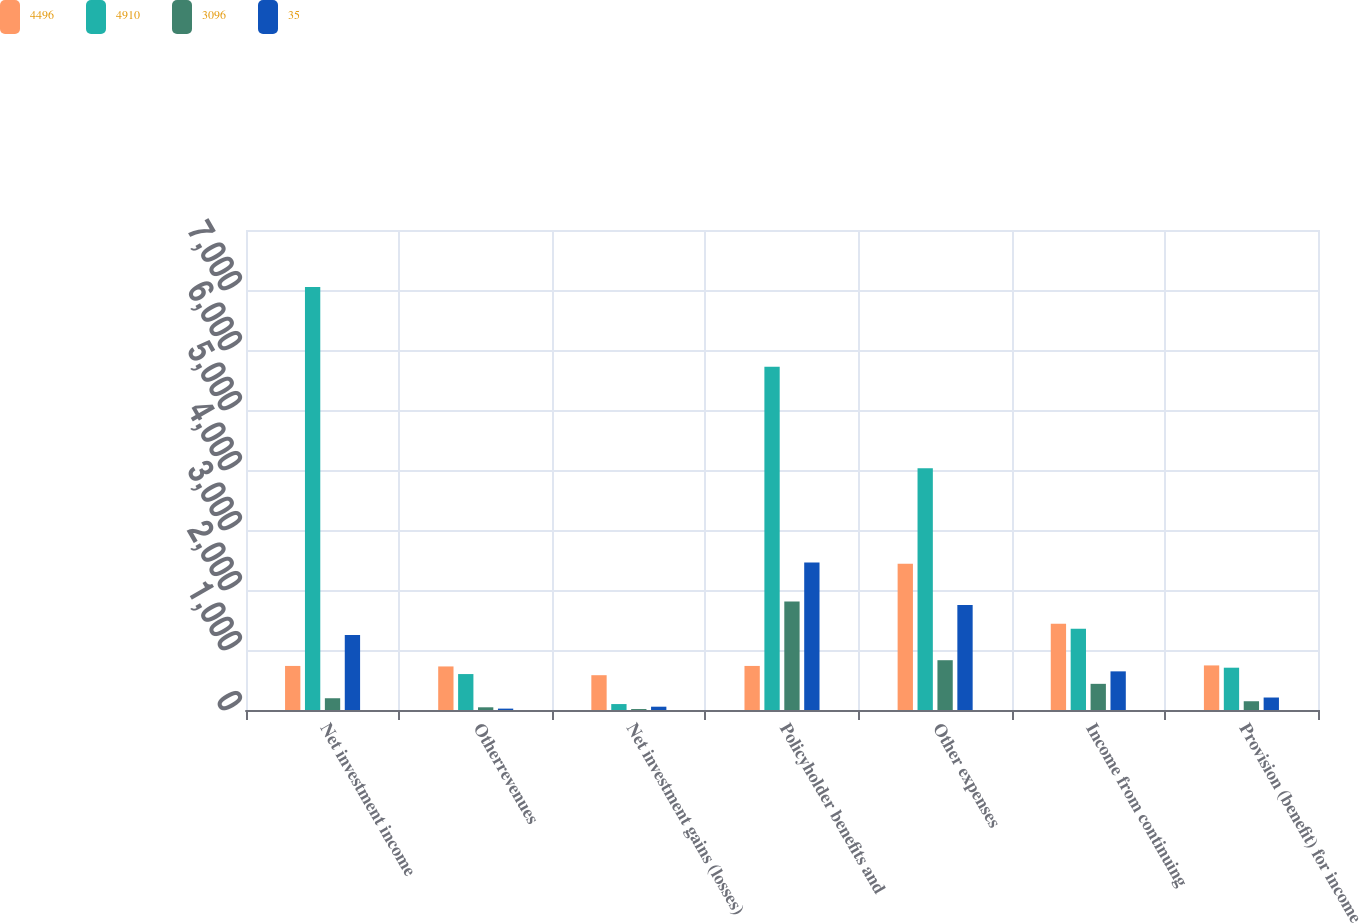Convert chart. <chart><loc_0><loc_0><loc_500><loc_500><stacked_bar_chart><ecel><fcel>Net investment income<fcel>Otherrevenues<fcel>Net investment gains (losses)<fcel>Policyholder benefits and<fcel>Other expenses<fcel>Income from continuing<fcel>Provision (benefit) for income<nl><fcel>4496<fcel>734.5<fcel>726<fcel>580<fcel>734.5<fcel>2438<fcel>1439<fcel>743<nl><fcel>4910<fcel>7052<fcel>599<fcel>99<fcel>5721<fcel>4031<fcel>1356<fcel>705<nl><fcel>3096<fcel>196<fcel>45<fcel>16<fcel>1807<fcel>830<fcel>436<fcel>146<nl><fcel>35<fcel>1248<fcel>23<fcel>55<fcel>2458<fcel>1748<fcel>644<fcel>208<nl></chart> 